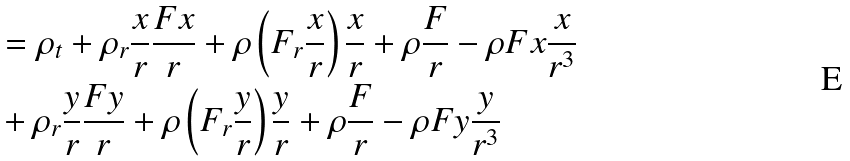<formula> <loc_0><loc_0><loc_500><loc_500>& = \rho _ { t } + \rho _ { r } \frac { x } { r } \frac { F x } { r } + \rho \left ( F _ { r } \frac { x } { r } \right ) \frac { x } { r } + \rho \frac { F } { r } - \rho F x \frac { x } { r ^ { 3 } } \\ & + \rho _ { r } \frac { y } { r } \frac { F y } { r } + \rho \left ( F _ { r } \frac { y } { r } \right ) \frac { y } { r } + \rho \frac { F } { r } - \rho F y \frac { y } { r ^ { 3 } }</formula> 